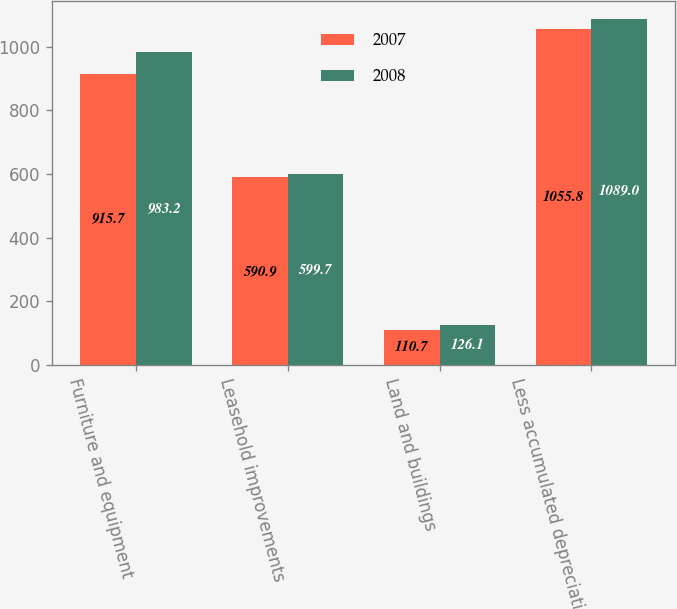Convert chart to OTSL. <chart><loc_0><loc_0><loc_500><loc_500><stacked_bar_chart><ecel><fcel>Furniture and equipment<fcel>Leasehold improvements<fcel>Land and buildings<fcel>Less accumulated depreciation<nl><fcel>2007<fcel>915.7<fcel>590.9<fcel>110.7<fcel>1055.8<nl><fcel>2008<fcel>983.2<fcel>599.7<fcel>126.1<fcel>1089<nl></chart> 